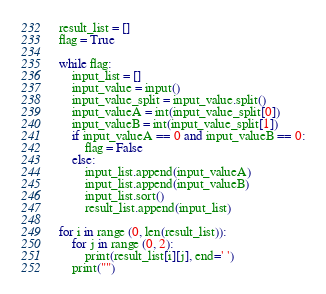<code> <loc_0><loc_0><loc_500><loc_500><_Python_>result_list = []
flag = True

while flag:
	input_list = []
	input_value = input()
	input_value_split = input_value.split()
	input_valueA = int(input_value_split[0])
	input_valueB = int(input_value_split[1])
	if input_valueA == 0 and input_valueB == 0:
		flag = False
	else:
		input_list.append(input_valueA)
		input_list.append(input_valueB)
		input_list.sort()
		result_list.append(input_list)

for i in range (0, len(result_list)):
	for j in range (0, 2):
		print(result_list[i][j], end=' ')
	print("")</code> 